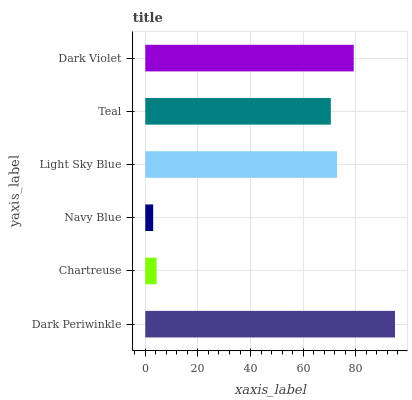Is Navy Blue the minimum?
Answer yes or no. Yes. Is Dark Periwinkle the maximum?
Answer yes or no. Yes. Is Chartreuse the minimum?
Answer yes or no. No. Is Chartreuse the maximum?
Answer yes or no. No. Is Dark Periwinkle greater than Chartreuse?
Answer yes or no. Yes. Is Chartreuse less than Dark Periwinkle?
Answer yes or no. Yes. Is Chartreuse greater than Dark Periwinkle?
Answer yes or no. No. Is Dark Periwinkle less than Chartreuse?
Answer yes or no. No. Is Light Sky Blue the high median?
Answer yes or no. Yes. Is Teal the low median?
Answer yes or no. Yes. Is Navy Blue the high median?
Answer yes or no. No. Is Dark Violet the low median?
Answer yes or no. No. 